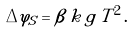Convert formula to latex. <formula><loc_0><loc_0><loc_500><loc_500>\Delta \varphi _ { S } = \beta \, k \, g \, T ^ { 2 } \, .</formula> 